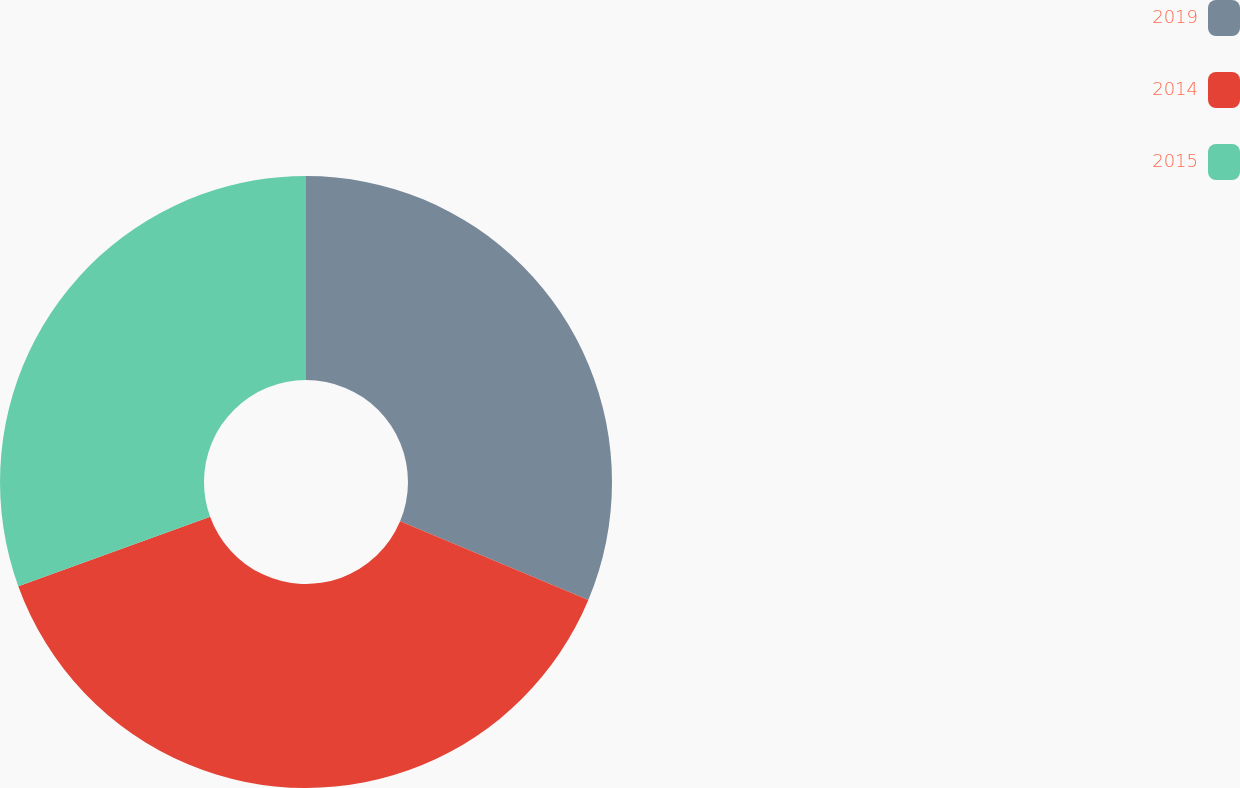<chart> <loc_0><loc_0><loc_500><loc_500><pie_chart><fcel>2019<fcel>2014<fcel>2015<nl><fcel>31.3%<fcel>38.17%<fcel>30.53%<nl></chart> 